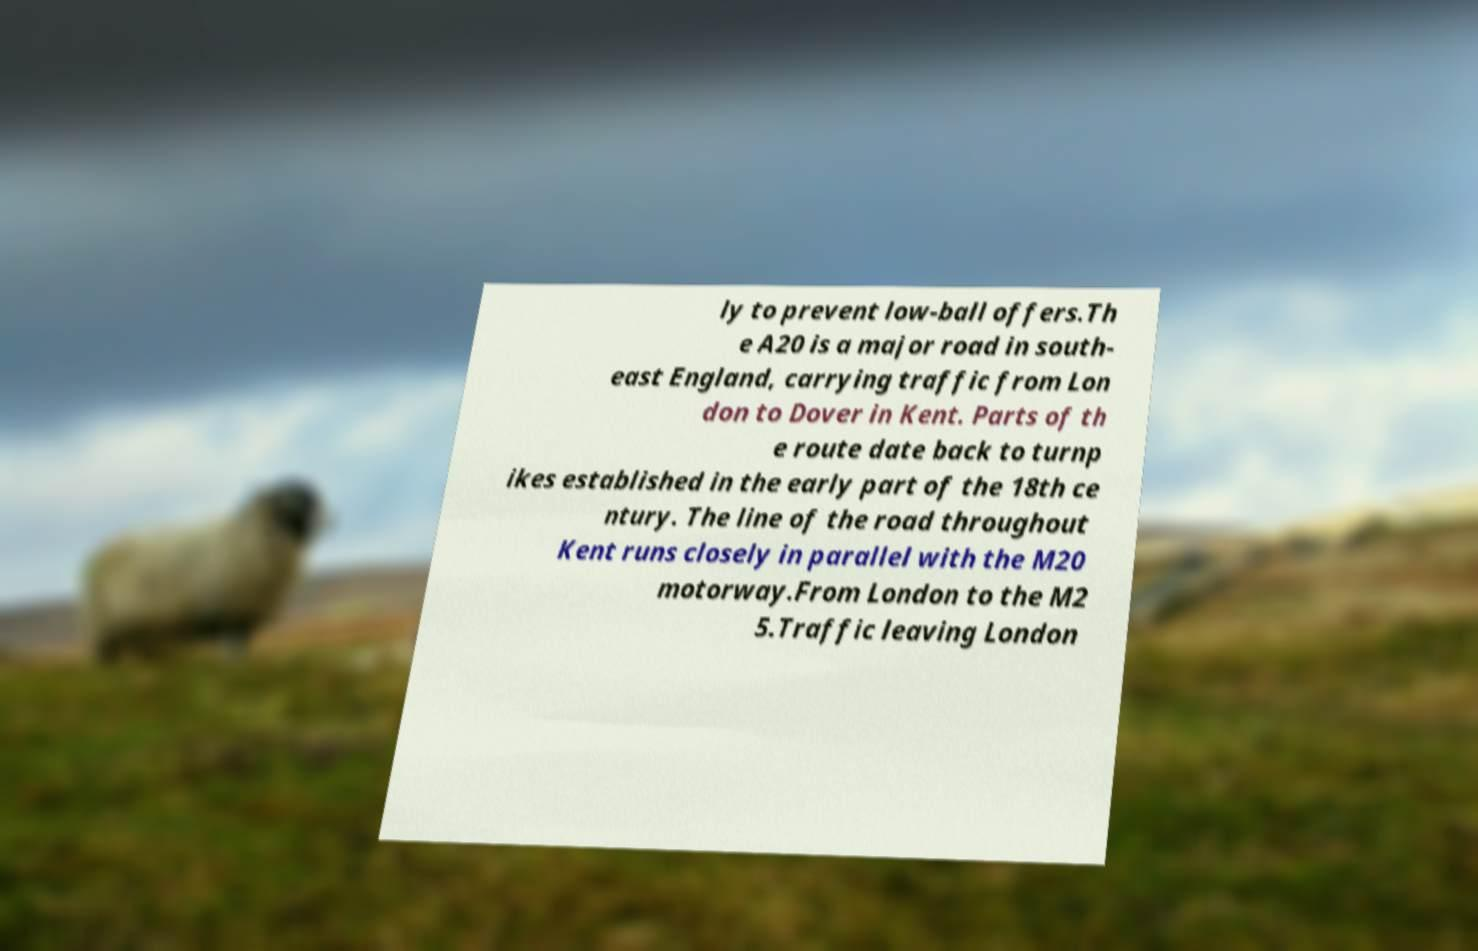Please read and relay the text visible in this image. What does it say? ly to prevent low-ball offers.Th e A20 is a major road in south- east England, carrying traffic from Lon don to Dover in Kent. Parts of th e route date back to turnp ikes established in the early part of the 18th ce ntury. The line of the road throughout Kent runs closely in parallel with the M20 motorway.From London to the M2 5.Traffic leaving London 